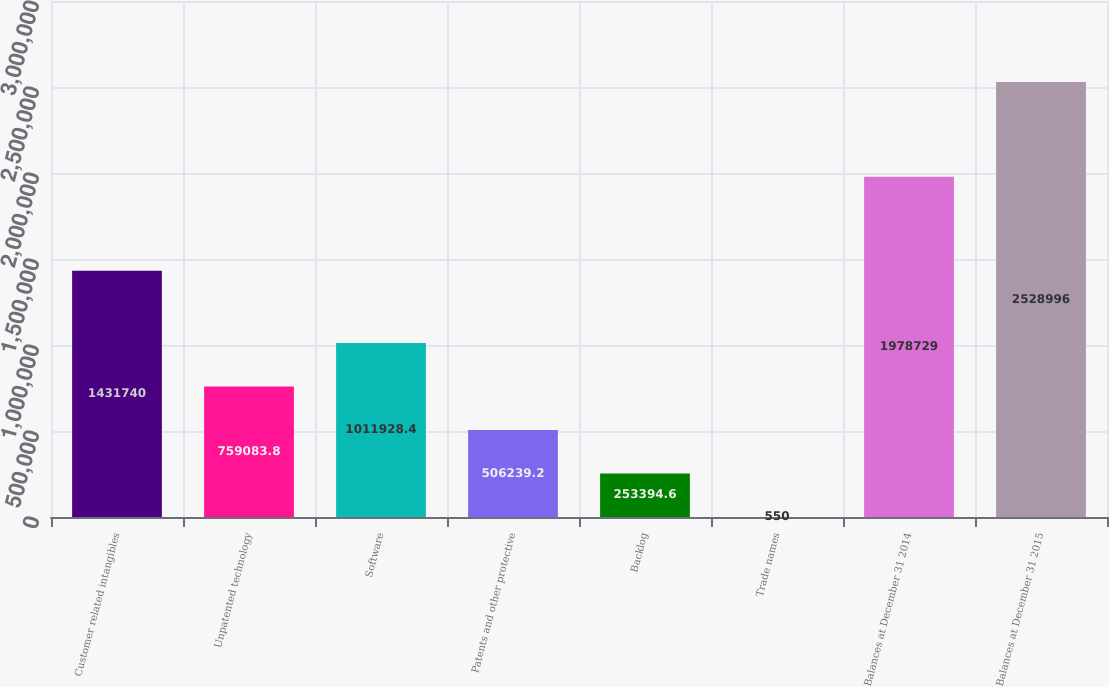Convert chart. <chart><loc_0><loc_0><loc_500><loc_500><bar_chart><fcel>Customer related intangibles<fcel>Unpatented technology<fcel>Software<fcel>Patents and other protective<fcel>Backlog<fcel>Trade names<fcel>Balances at December 31 2014<fcel>Balances at December 31 2015<nl><fcel>1.43174e+06<fcel>759084<fcel>1.01193e+06<fcel>506239<fcel>253395<fcel>550<fcel>1.97873e+06<fcel>2.529e+06<nl></chart> 